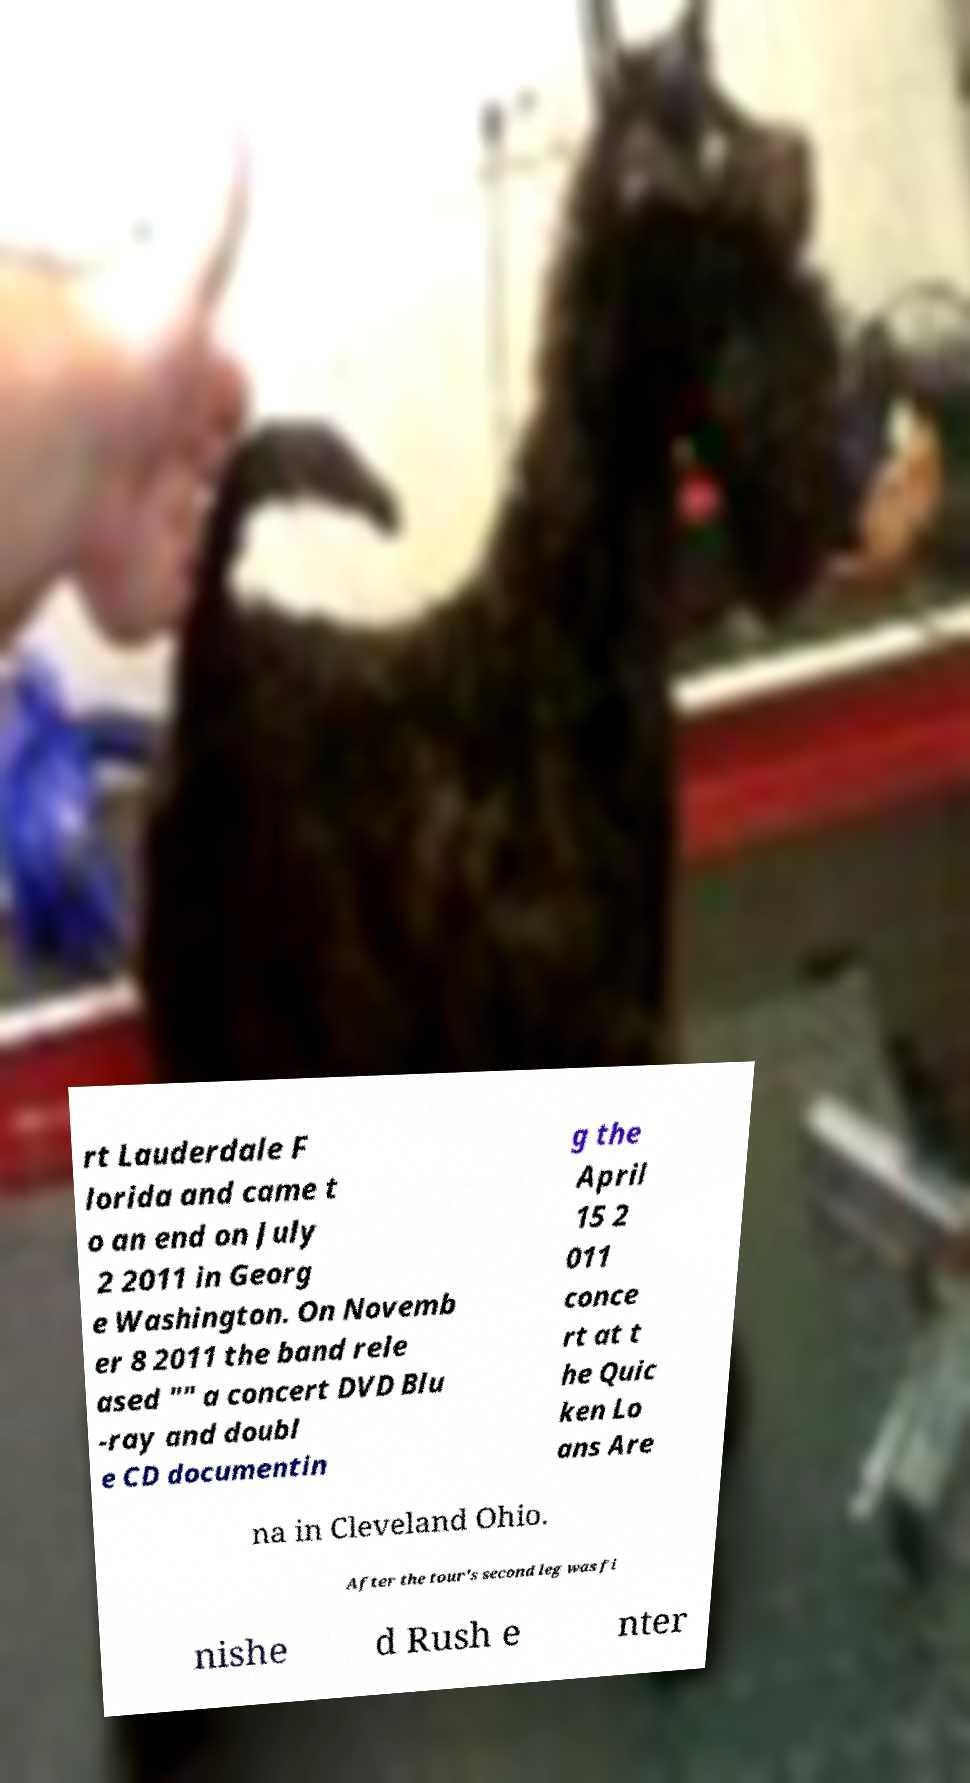Can you read and provide the text displayed in the image?This photo seems to have some interesting text. Can you extract and type it out for me? rt Lauderdale F lorida and came t o an end on July 2 2011 in Georg e Washington. On Novemb er 8 2011 the band rele ased "" a concert DVD Blu -ray and doubl e CD documentin g the April 15 2 011 conce rt at t he Quic ken Lo ans Are na in Cleveland Ohio. After the tour's second leg was fi nishe d Rush e nter 